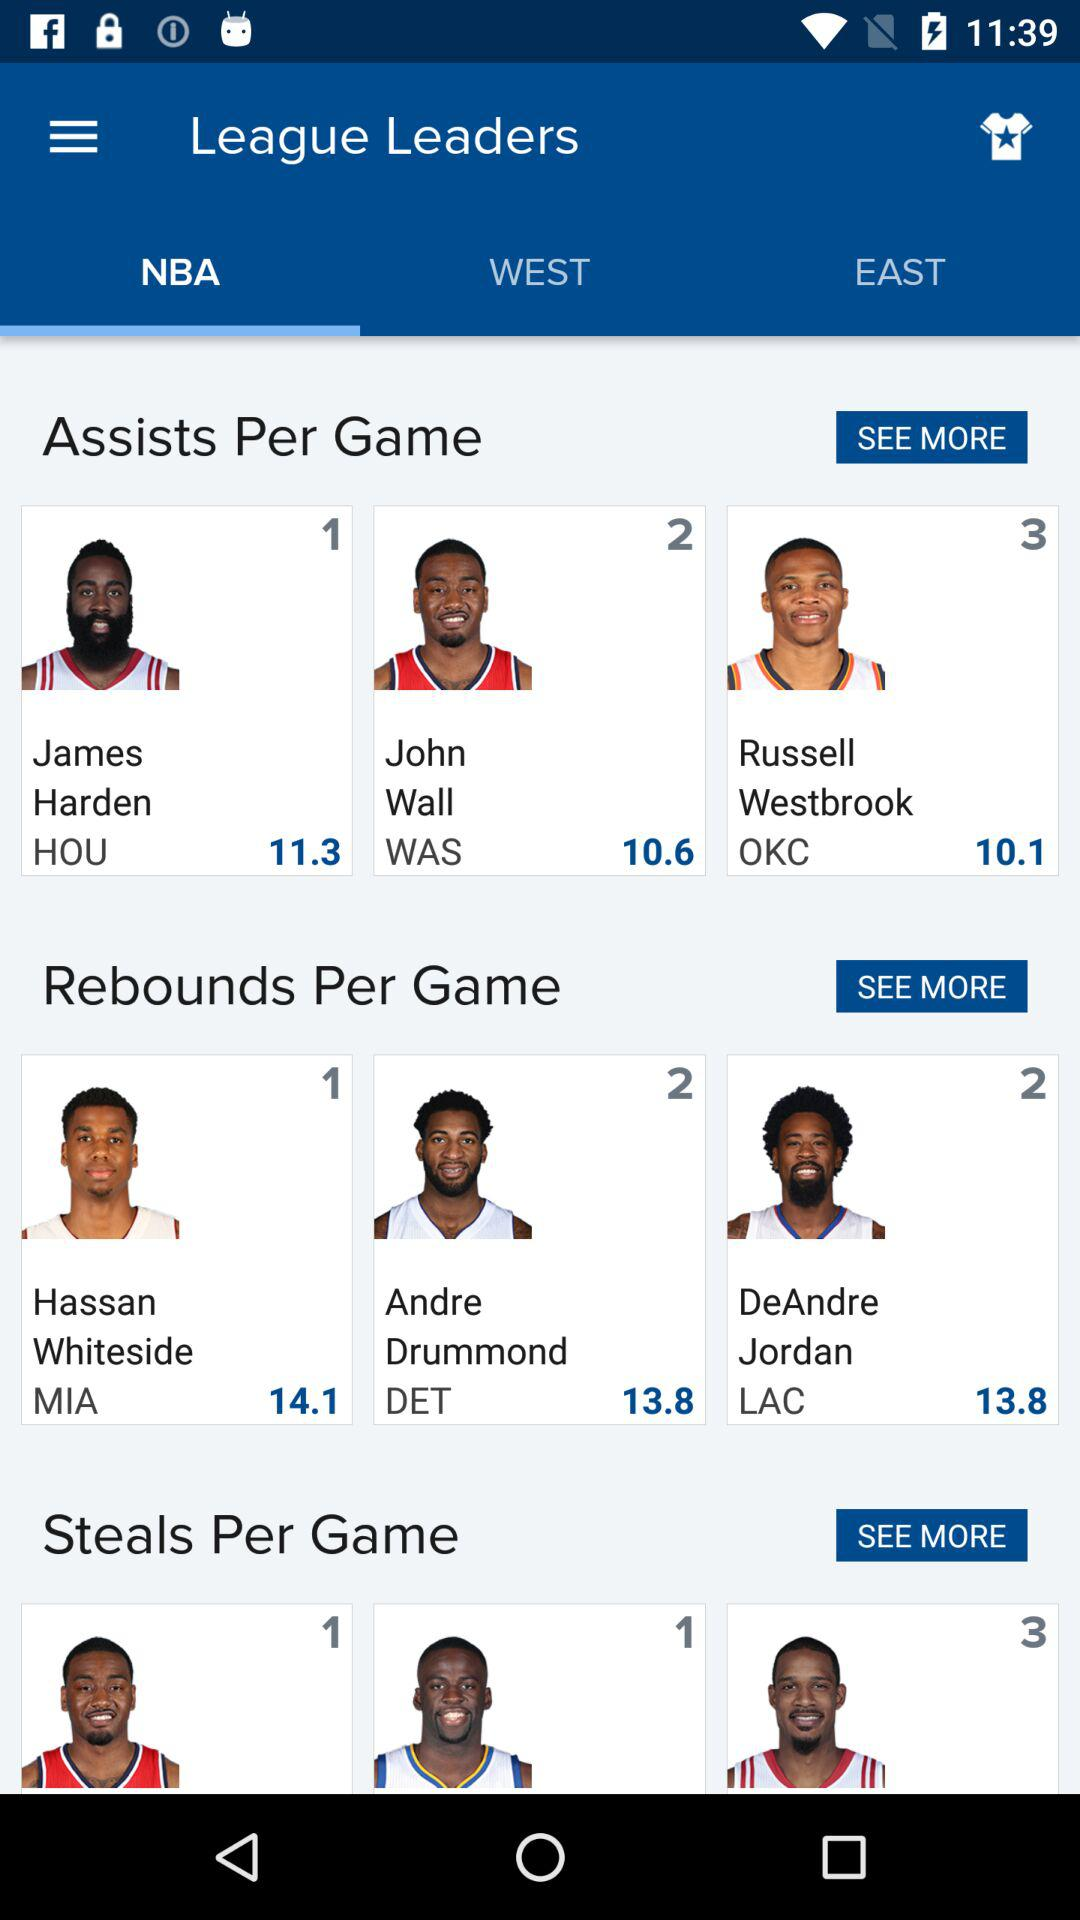Which tab is selected? The selected tab is "NBA". 